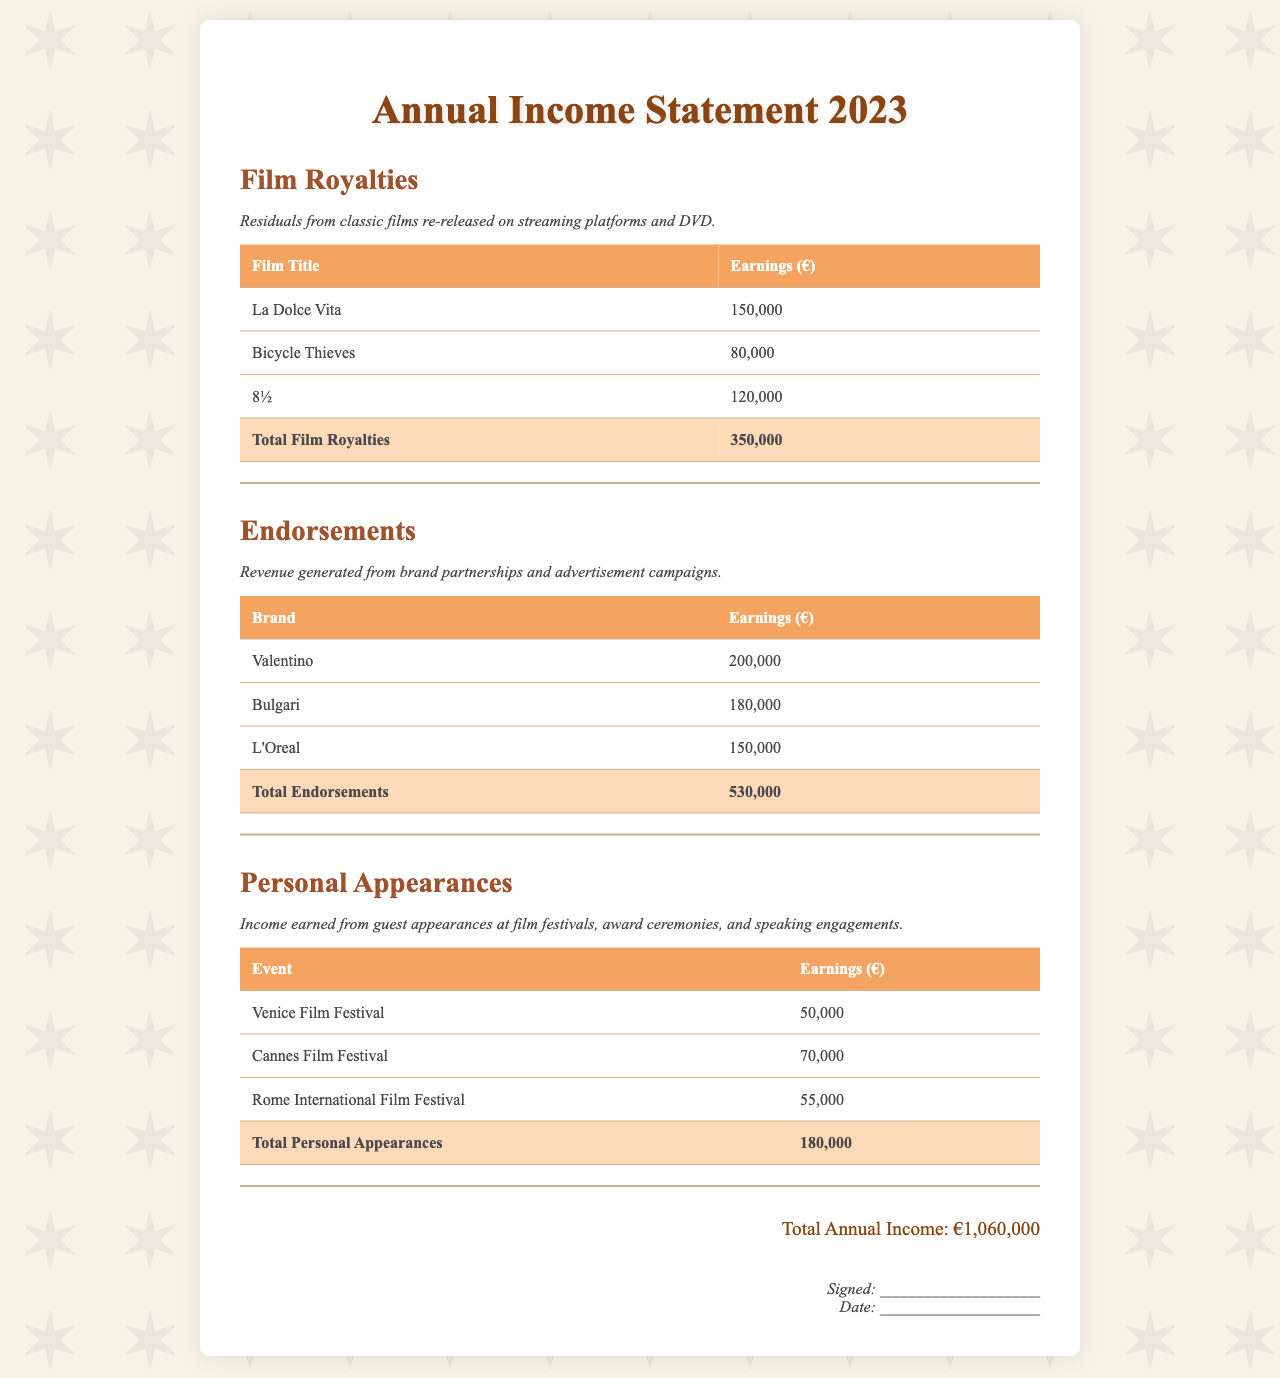What is the total income from film royalties? The total income from film royalties is listed in the document as 350,000 euros.
Answer: 350,000 How much did endorsements earn in total? The total endorsements earnings are summarized in the document as 530,000 euros.
Answer: 530,000 What event generated the highest earnings in personal appearances? The table under personal appearances indicates that the Cannes Film Festival generated the highest earnings of 70,000 euros.
Answer: Cannes Film Festival What is the total annual income reported for 2023? The total annual income combines all income sources, amounting to 1,060,000 euros as per the document.
Answer: 1,060,000 Which film generated the highest royalties? The highest earning film is La Dolce Vita, with earnings of 150,000 euros.
Answer: La Dolce Vita What is the earnings from L'Oreal endorsements? The document specifies the earnings from L'Oreal endorsements as 150,000 euros.
Answer: 150,000 How many total sources of income are listed in the document? The document lists three sources of income: Film Royalties, Endorsements, and Personal Appearances.
Answer: Three Which type of income has the lowest total earnings? Personal Appearances have the lowest total earnings compared to Film Royalties and Endorsements.
Answer: Personal Appearances What is the purpose of this document? The document serves as an annual income statement summarizing the actress's earnings for the year 2023.
Answer: Annual income statement 